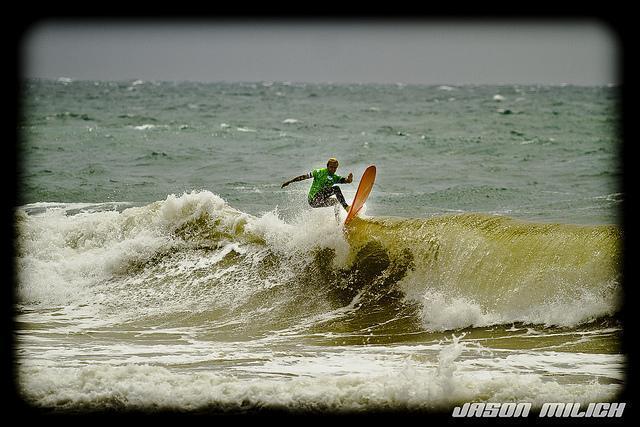How many people are shown?
Give a very brief answer. 1. 